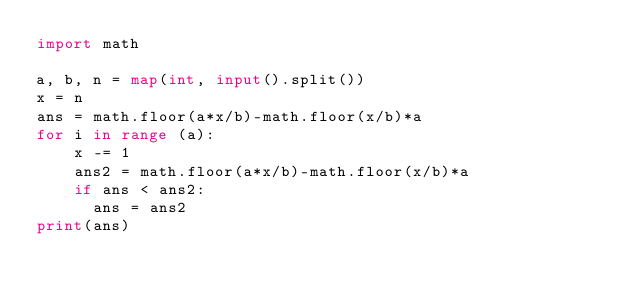<code> <loc_0><loc_0><loc_500><loc_500><_Python_>import math

a, b, n = map(int, input().split())
x = n
ans = math.floor(a*x/b)-math.floor(x/b)*a
for i in range (a):
    x -= 1
    ans2 = math.floor(a*x/b)-math.floor(x/b)*a
    if ans < ans2:
      ans = ans2
print(ans)</code> 